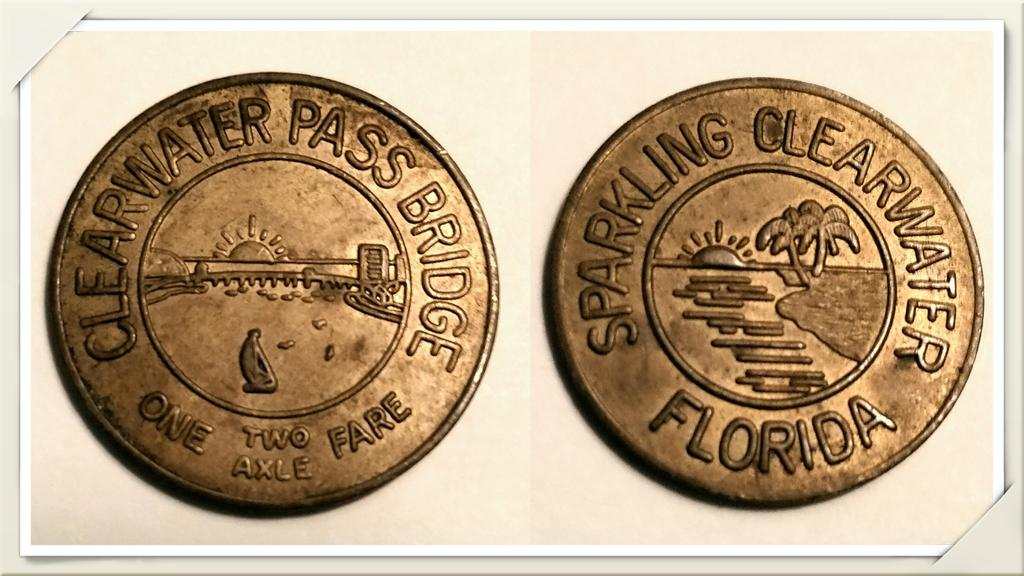<image>
Share a concise interpretation of the image provided. Clearwater Pass Bridge, Sparkling Clearwater Florida is etched onto these two coins. 